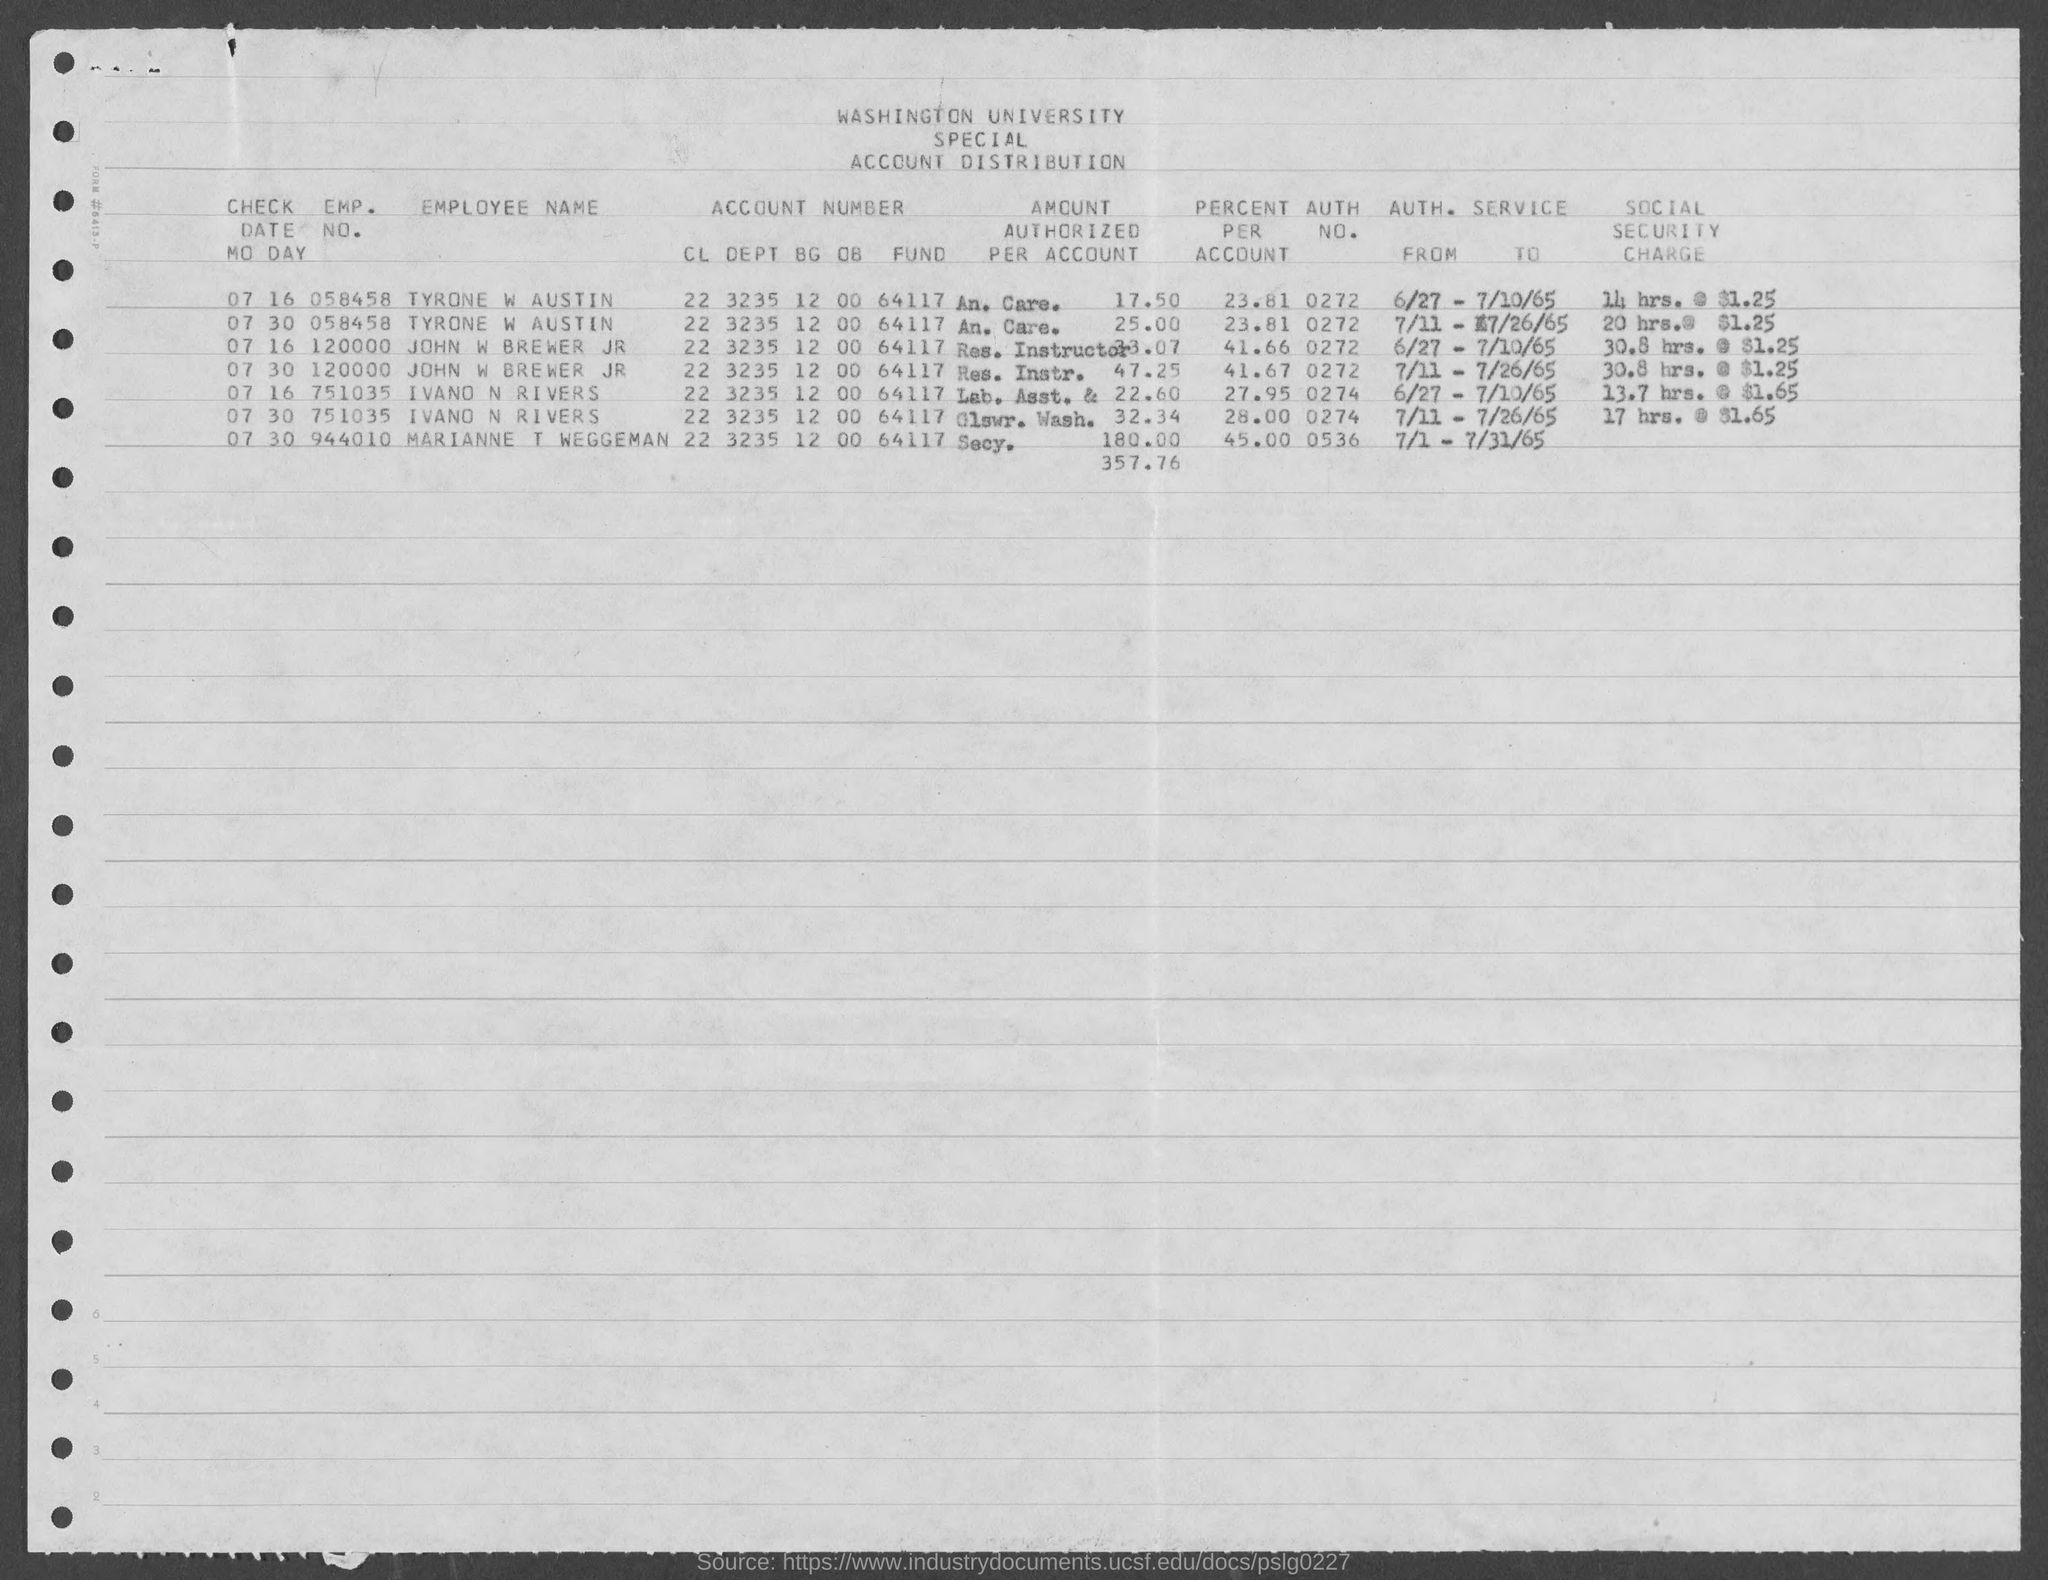List a handful of essential elements in this visual. The percentage of Tyrone W Austin is 23.81%. The authorization number for John W. Brewer Jr. is 0272. The percentage of Marianne T Weggeman is 45.00%. The employment number of Ivano N Rivers is 751035. The authoritative number for Tyrone W Austin is 0272... 